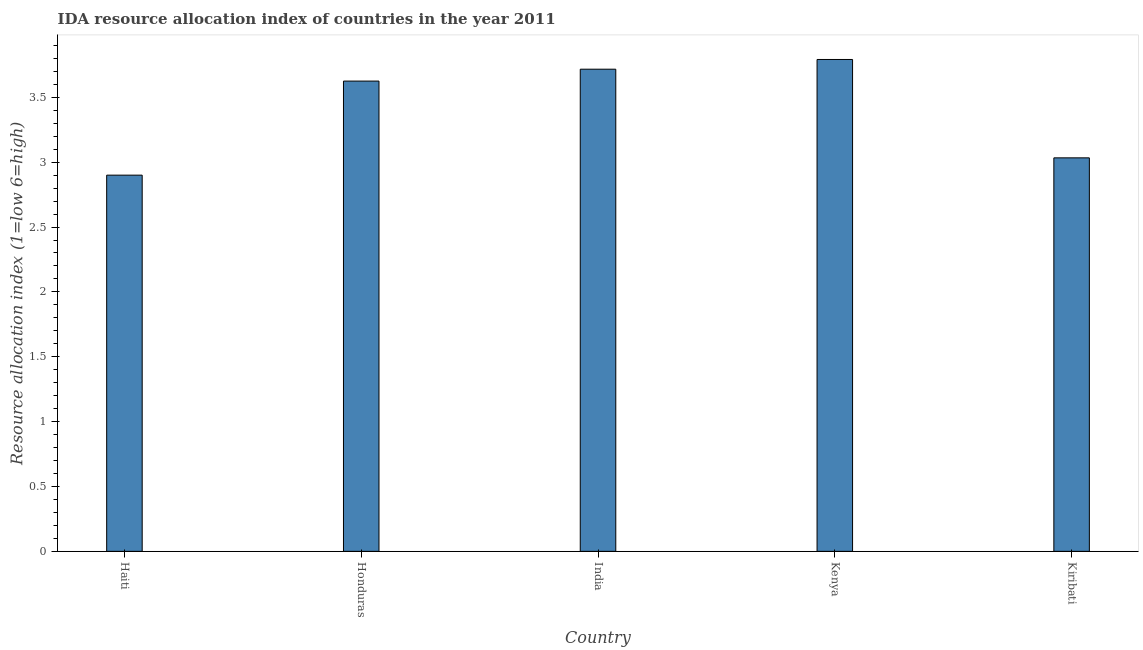What is the title of the graph?
Offer a terse response. IDA resource allocation index of countries in the year 2011. What is the label or title of the X-axis?
Provide a succinct answer. Country. What is the label or title of the Y-axis?
Your answer should be very brief. Resource allocation index (1=low 6=high). What is the ida resource allocation index in India?
Provide a succinct answer. 3.72. Across all countries, what is the maximum ida resource allocation index?
Give a very brief answer. 3.79. In which country was the ida resource allocation index maximum?
Your response must be concise. Kenya. In which country was the ida resource allocation index minimum?
Give a very brief answer. Haiti. What is the sum of the ida resource allocation index?
Keep it short and to the point. 17.07. What is the difference between the ida resource allocation index in Honduras and Kiribati?
Ensure brevity in your answer.  0.59. What is the average ida resource allocation index per country?
Your answer should be compact. 3.41. What is the median ida resource allocation index?
Offer a very short reply. 3.62. What is the ratio of the ida resource allocation index in Honduras to that in Kiribati?
Your answer should be very brief. 1.2. Is the ida resource allocation index in Haiti less than that in India?
Your answer should be very brief. Yes. Is the difference between the ida resource allocation index in Haiti and Honduras greater than the difference between any two countries?
Provide a short and direct response. No. What is the difference between the highest and the second highest ida resource allocation index?
Offer a terse response. 0.07. What is the difference between the highest and the lowest ida resource allocation index?
Make the answer very short. 0.89. How many countries are there in the graph?
Your response must be concise. 5. What is the difference between two consecutive major ticks on the Y-axis?
Provide a short and direct response. 0.5. Are the values on the major ticks of Y-axis written in scientific E-notation?
Keep it short and to the point. No. What is the Resource allocation index (1=low 6=high) of Honduras?
Keep it short and to the point. 3.62. What is the Resource allocation index (1=low 6=high) of India?
Keep it short and to the point. 3.72. What is the Resource allocation index (1=low 6=high) in Kenya?
Offer a very short reply. 3.79. What is the Resource allocation index (1=low 6=high) of Kiribati?
Ensure brevity in your answer.  3.03. What is the difference between the Resource allocation index (1=low 6=high) in Haiti and Honduras?
Your answer should be very brief. -0.72. What is the difference between the Resource allocation index (1=low 6=high) in Haiti and India?
Your response must be concise. -0.82. What is the difference between the Resource allocation index (1=low 6=high) in Haiti and Kenya?
Ensure brevity in your answer.  -0.89. What is the difference between the Resource allocation index (1=low 6=high) in Haiti and Kiribati?
Provide a succinct answer. -0.13. What is the difference between the Resource allocation index (1=low 6=high) in Honduras and India?
Keep it short and to the point. -0.09. What is the difference between the Resource allocation index (1=low 6=high) in Honduras and Kenya?
Make the answer very short. -0.17. What is the difference between the Resource allocation index (1=low 6=high) in Honduras and Kiribati?
Offer a very short reply. 0.59. What is the difference between the Resource allocation index (1=low 6=high) in India and Kenya?
Offer a terse response. -0.07. What is the difference between the Resource allocation index (1=low 6=high) in India and Kiribati?
Your response must be concise. 0.68. What is the difference between the Resource allocation index (1=low 6=high) in Kenya and Kiribati?
Provide a short and direct response. 0.76. What is the ratio of the Resource allocation index (1=low 6=high) in Haiti to that in Honduras?
Provide a short and direct response. 0.8. What is the ratio of the Resource allocation index (1=low 6=high) in Haiti to that in India?
Your answer should be very brief. 0.78. What is the ratio of the Resource allocation index (1=low 6=high) in Haiti to that in Kenya?
Offer a terse response. 0.77. What is the ratio of the Resource allocation index (1=low 6=high) in Haiti to that in Kiribati?
Your response must be concise. 0.96. What is the ratio of the Resource allocation index (1=low 6=high) in Honduras to that in India?
Keep it short and to the point. 0.97. What is the ratio of the Resource allocation index (1=low 6=high) in Honduras to that in Kenya?
Offer a terse response. 0.96. What is the ratio of the Resource allocation index (1=low 6=high) in Honduras to that in Kiribati?
Ensure brevity in your answer.  1.2. What is the ratio of the Resource allocation index (1=low 6=high) in India to that in Kiribati?
Offer a terse response. 1.23. What is the ratio of the Resource allocation index (1=low 6=high) in Kenya to that in Kiribati?
Your answer should be compact. 1.25. 